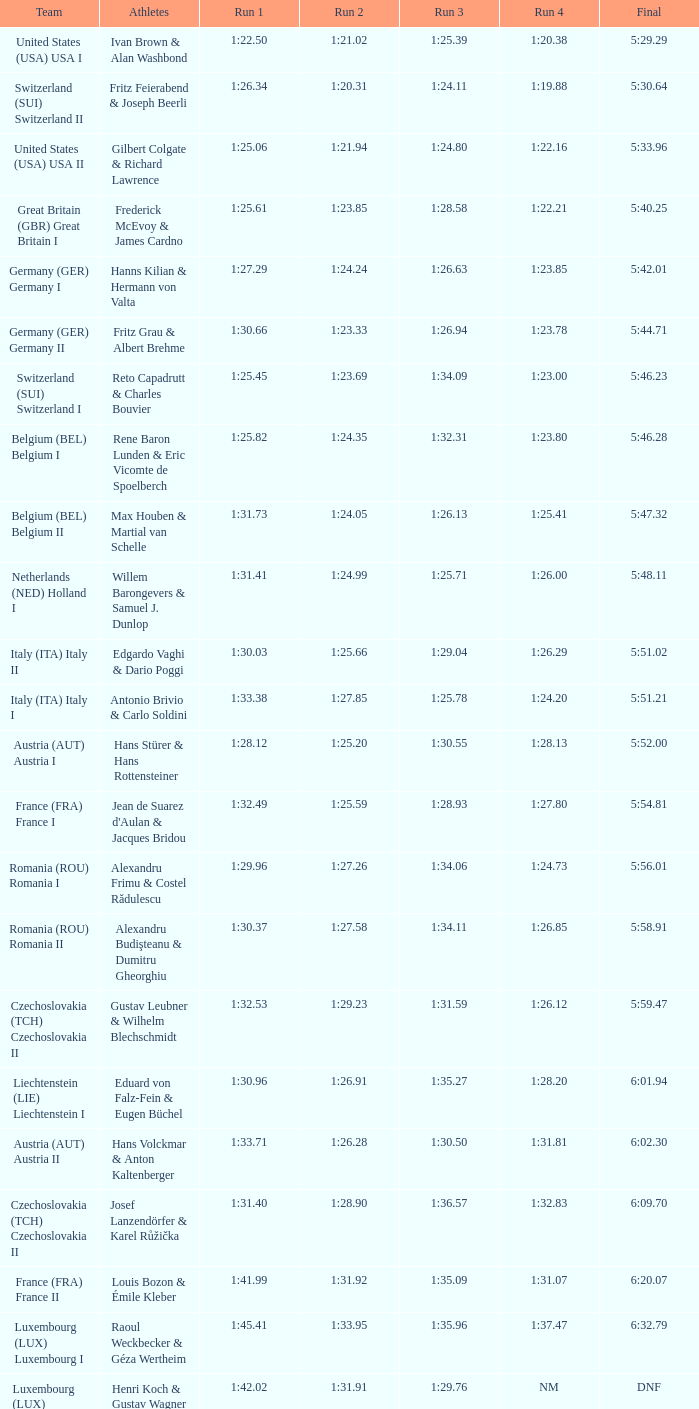Which Final has a Team of liechtenstein (lie) liechtenstein i? 6:01.94. 